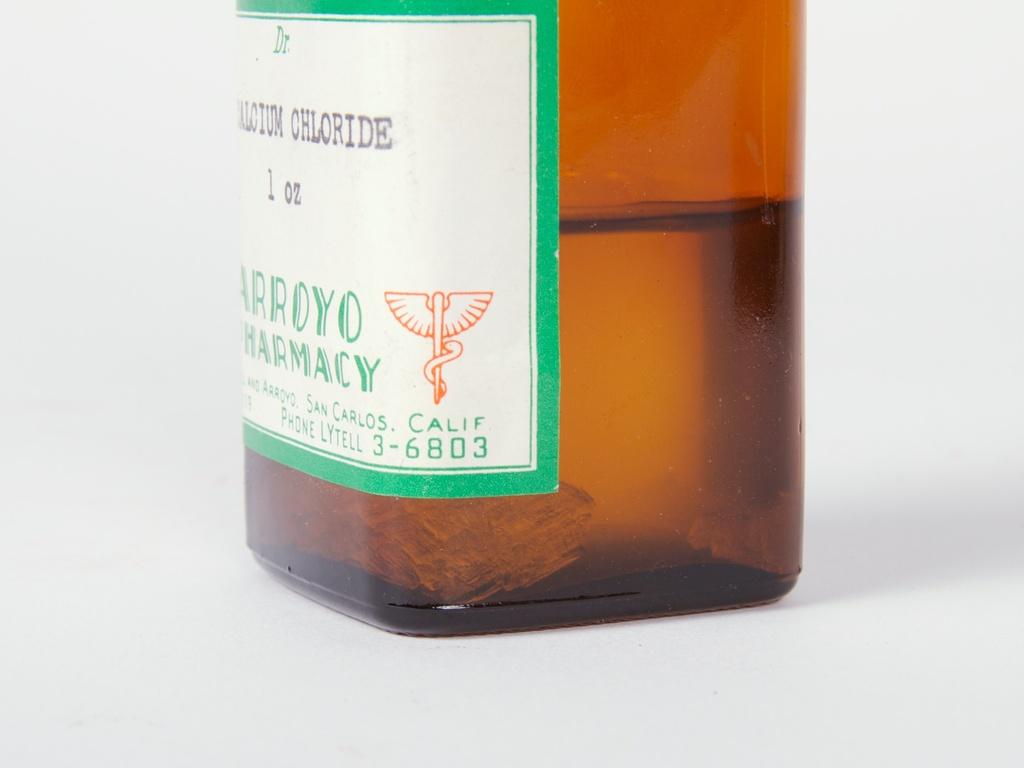What type of liquid is this?
Give a very brief answer. Calcium chloride. Where was this made?
Keep it short and to the point. California. 